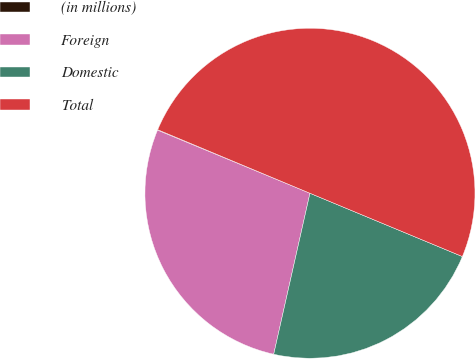Convert chart to OTSL. <chart><loc_0><loc_0><loc_500><loc_500><pie_chart><fcel>(in millions)<fcel>Foreign<fcel>Domestic<fcel>Total<nl><fcel>0.05%<fcel>27.72%<fcel>22.26%<fcel>49.97%<nl></chart> 